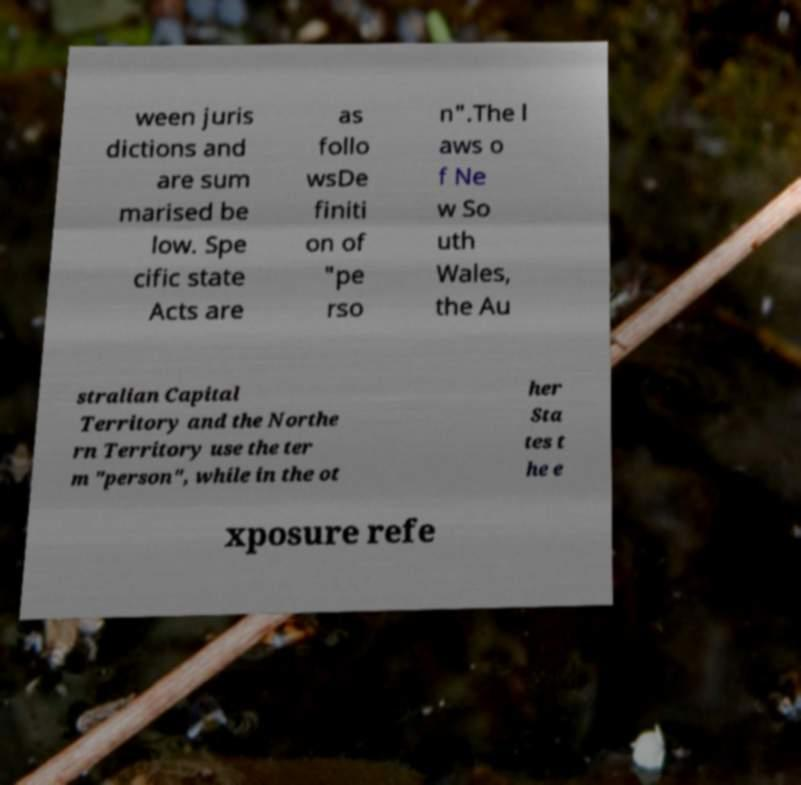Can you accurately transcribe the text from the provided image for me? ween juris dictions and are sum marised be low. Spe cific state Acts are as follo wsDe finiti on of "pe rso n".The l aws o f Ne w So uth Wales, the Au stralian Capital Territory and the Northe rn Territory use the ter m "person", while in the ot her Sta tes t he e xposure refe 